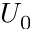Convert formula to latex. <formula><loc_0><loc_0><loc_500><loc_500>U _ { 0 }</formula> 